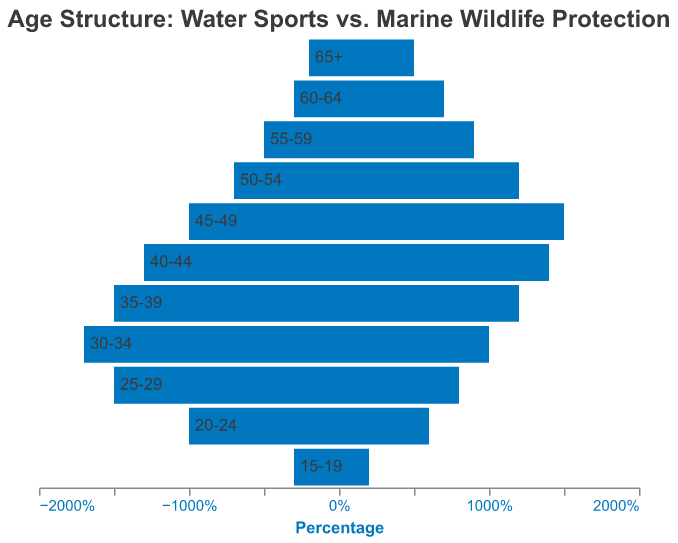How does the age distribution of employees in the 15-19 age group compare between the water sports industry and marine wildlife protection organizations? The water sports industry has 3% employees in the 15-19 age group, while marine wildlife protection organizations have 2%. To compare, we simply note which value is larger.
Answer: Water sports industry has a higher percentage Which age group has the highest percentage of employees in the water sports industry? We look at the bars on the negative side (left side) of the chart and identify the age group with the longest bar, which corresponds to the highest percentage in the water sports industry.
Answer: 30-34 What is the combined percentage of employees aged 50-54 in both sectors? For the 50-54 age group, the water sports industry has 7% and the marine wildlife protection organizations have 12%. We add these percentages together to get the sum. 7% + 12% = 19%
Answer: 19% Is there any age group where both sectors have the same percentage of employees? We compare the bars for both sectors across all age groups. If we find an age group where the bars are equal in length, they have the same percentage.
Answer: Yes, 40-44 Which sector has a higher percentage of employees in the 60-64 age group? We compare the lengths of the bars for the 60-64 age group. The marine wildlife protection bar (right side) is longer than the water sports industry bar (left side).
Answer: Marine wildlife protection What is the percentage difference between the two sectors for employees aged 25-29? The water sports industry has 15% and marine wildlife protection has 8% for the 25-29 age group. The percentage difference is calculated as 15% - 8% = 7%.
Answer: 7% Looking at the age group 45-49, what is the ratio of employees in marine wildlife protection to those in the water sports industry? The water sports industry has 10% and marine wildlife protection has 15% for the 45-49 age group. The ratio is calculated as 15/10 = 1.5.
Answer: 1.5 In which age group does the marine wildlife protection sector have its peak percentage of employees? Looking at the right side bars for marine wildlife protection, the longest one indicates the peak percentage. The peak is at the age group 45-49 with 15%.
Answer: 45-49 What percentage of employees in the water sports industry are under 25 years old? We sum the percentages of the 15-19 and 20-24 age groups in the water sports industry. 3% + 10% = 13%
Answer: 13% How does the percentage of employees aged 35-39 compare between the two sectors? The water sports industry has 15% and marine wildlife protection has 12% for the age group 35-39. Comparing these values, the water sports industry has a higher percentage.
Answer: Water sports industry has a higher percentage 